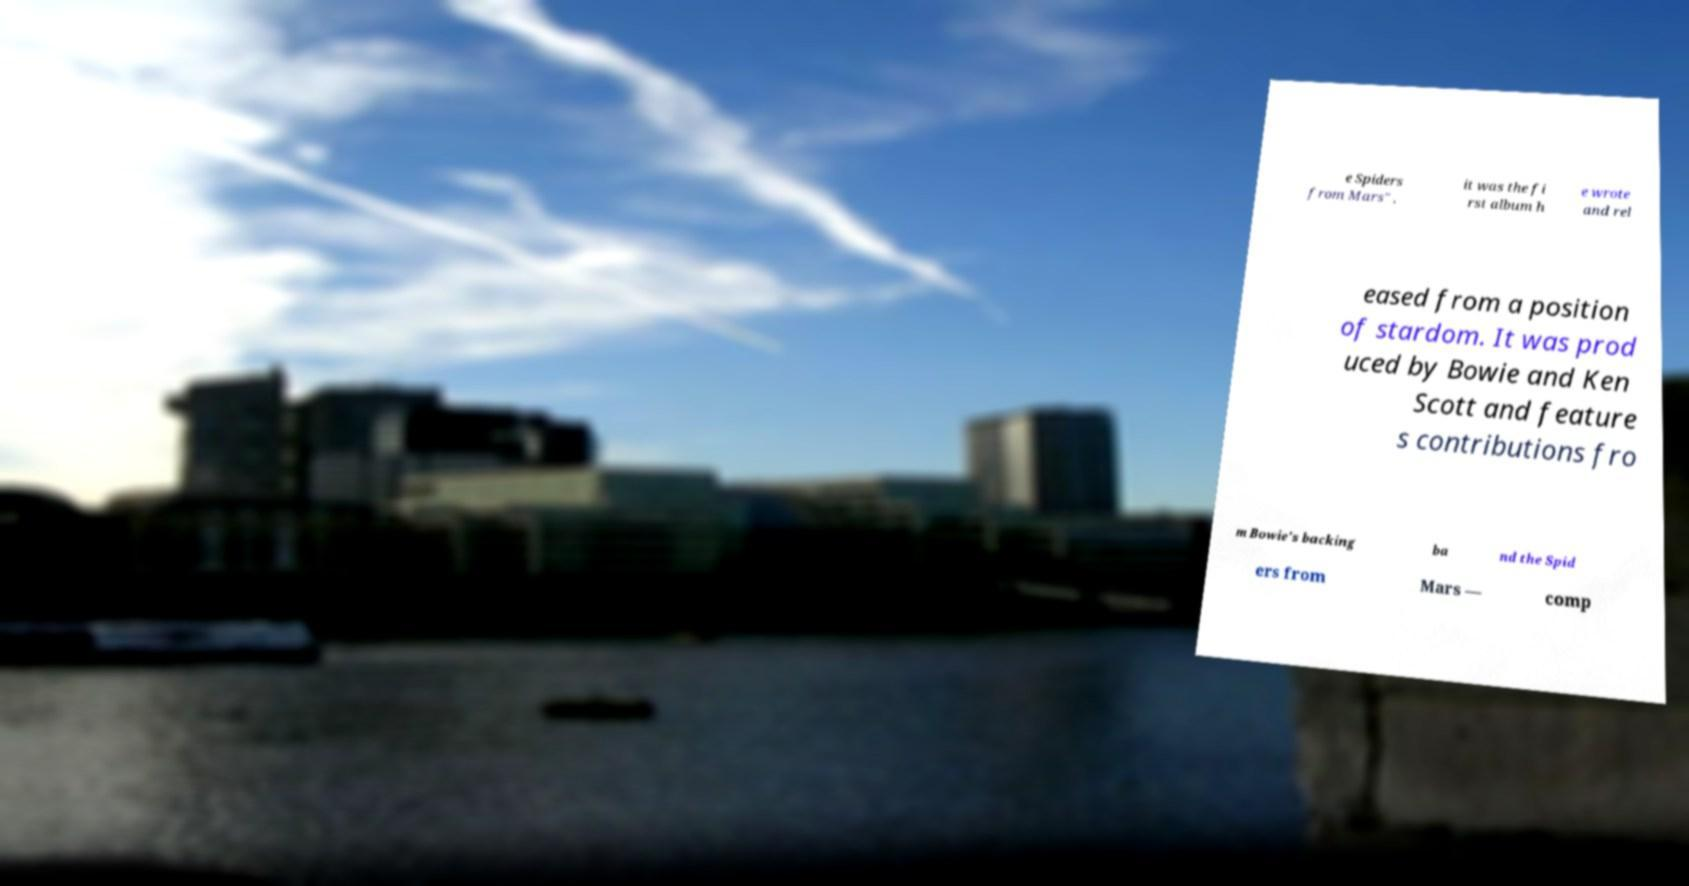Could you extract and type out the text from this image? e Spiders from Mars" , it was the fi rst album h e wrote and rel eased from a position of stardom. It was prod uced by Bowie and Ken Scott and feature s contributions fro m Bowie's backing ba nd the Spid ers from Mars — comp 